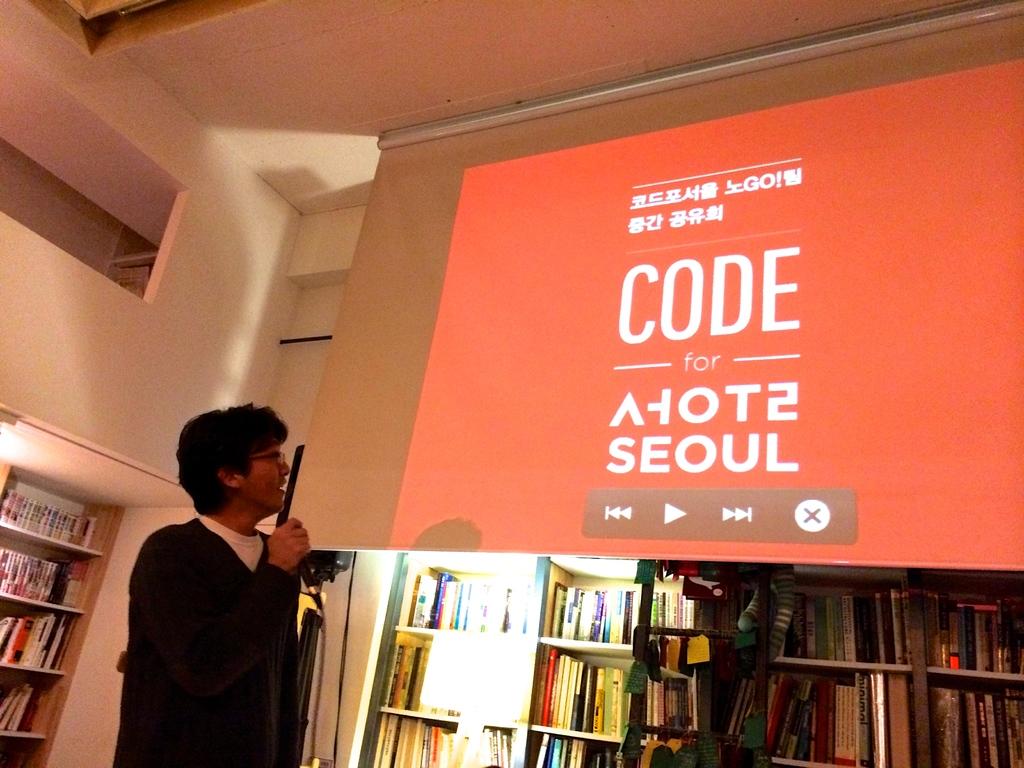Did he speaks about computer code?
Keep it short and to the point. Yes. What city is written above the play button?
Offer a terse response. Seoul. 